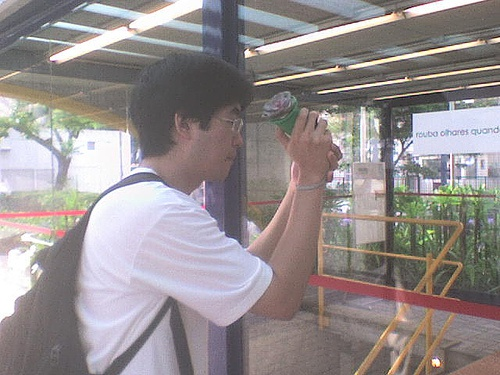Describe the objects in this image and their specific colors. I can see people in lavender, gray, and darkgray tones and backpack in lavender and gray tones in this image. 